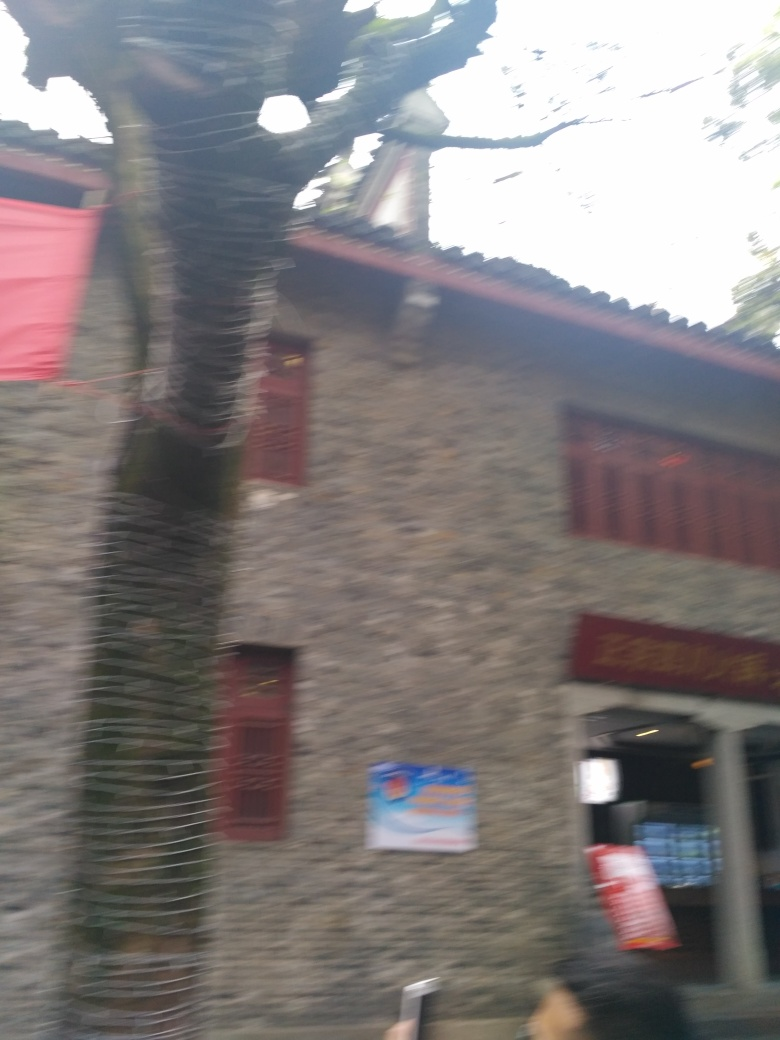What kind of building is shown in this image? The image displays what appears to be a traditional stone building with red window frames, possibly a residential structure or a part of a historic site, although the motion blur makes it difficult to discern specific architectural details. 